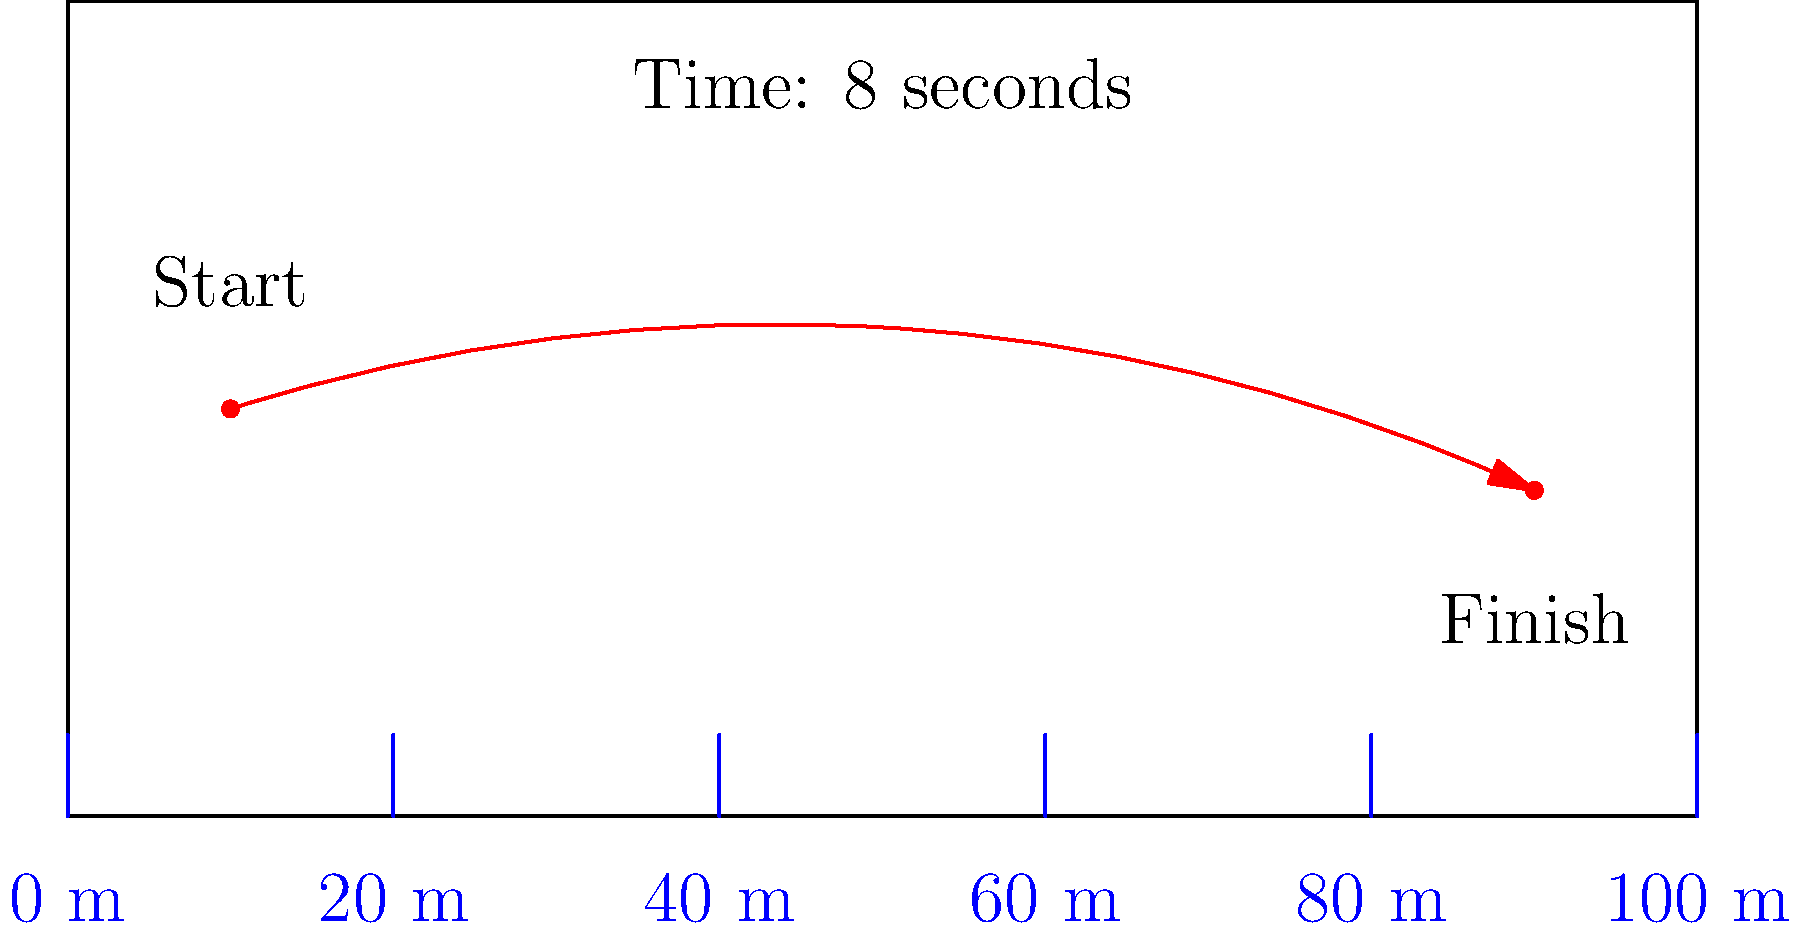As a referee, you need to determine if a player has exceeded the speed limit during a sprint across the field. The diagram shows the player's path from start to finish, with distance markers every 20 meters. If the player completed this run in 8 seconds, what was their average speed? Is this above or below the speed limit of 8 m/s? To solve this problem, we'll follow these steps:

1. Determine the distance traveled:
   - The player starts near the 10 m mark and finishes near the 90 m mark.
   - Total distance ≈ 90 m - 10 m = 80 m

2. Use the given time:
   - Time taken = 8 seconds

3. Calculate the average speed using the formula:
   $$ \text{Average Speed} = \frac{\text{Distance}}{\text{Time}} $$
   
   $$ \text{Average Speed} = \frac{80 \text{ m}}{8 \text{ s}} = 10 \text{ m/s} $$

4. Compare with the speed limit:
   - Speed limit = 8 m/s
   - Player's average speed = 10 m/s
   - 10 m/s > 8 m/s

Therefore, the player's average speed is 10 m/s, which is above the speed limit of 8 m/s.
Answer: 10 m/s; above limit 